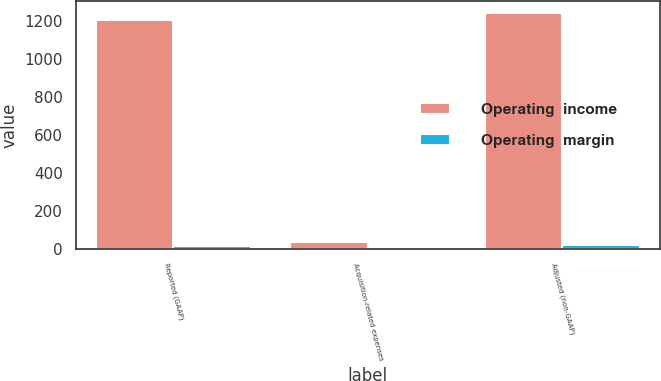Convert chart to OTSL. <chart><loc_0><loc_0><loc_500><loc_500><stacked_bar_chart><ecel><fcel>Reported (GAAP)<fcel>Acquisition-related expenses<fcel>Adjusted (non-GAAP)<nl><fcel>Operating  income<fcel>1205.2<fcel>36.6<fcel>1241.8<nl><fcel>Operating  margin<fcel>19.2<fcel>0.6<fcel>19.8<nl></chart> 